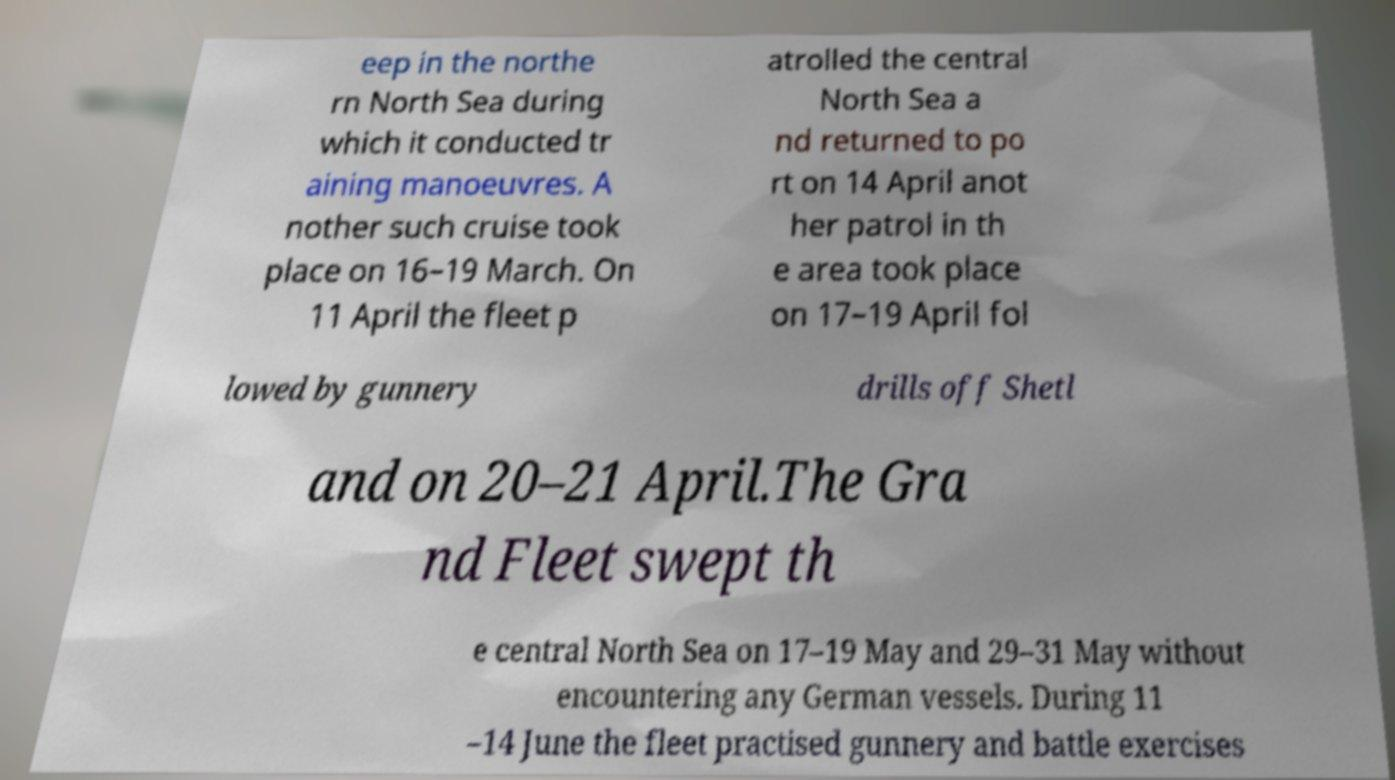What messages or text are displayed in this image? I need them in a readable, typed format. eep in the northe rn North Sea during which it conducted tr aining manoeuvres. A nother such cruise took place on 16–19 March. On 11 April the fleet p atrolled the central North Sea a nd returned to po rt on 14 April anot her patrol in th e area took place on 17–19 April fol lowed by gunnery drills off Shetl and on 20–21 April.The Gra nd Fleet swept th e central North Sea on 17–19 May and 29–31 May without encountering any German vessels. During 11 –14 June the fleet practised gunnery and battle exercises 